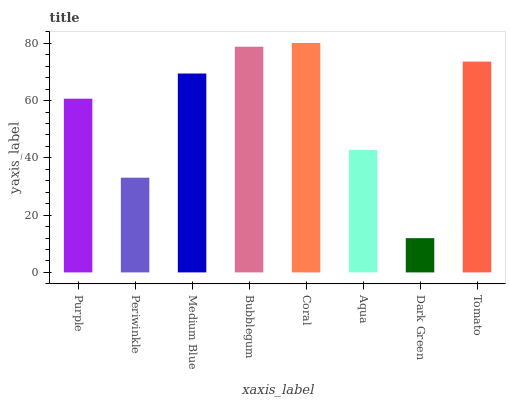Is Periwinkle the minimum?
Answer yes or no. No. Is Periwinkle the maximum?
Answer yes or no. No. Is Purple greater than Periwinkle?
Answer yes or no. Yes. Is Periwinkle less than Purple?
Answer yes or no. Yes. Is Periwinkle greater than Purple?
Answer yes or no. No. Is Purple less than Periwinkle?
Answer yes or no. No. Is Medium Blue the high median?
Answer yes or no. Yes. Is Purple the low median?
Answer yes or no. Yes. Is Bubblegum the high median?
Answer yes or no. No. Is Dark Green the low median?
Answer yes or no. No. 